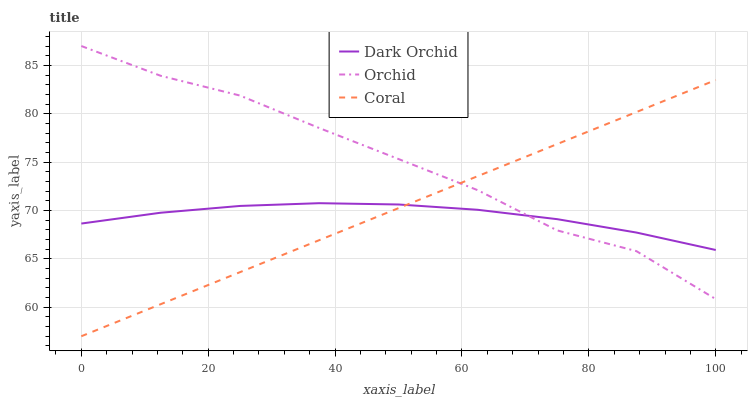Does Dark Orchid have the minimum area under the curve?
Answer yes or no. Yes. Does Orchid have the maximum area under the curve?
Answer yes or no. Yes. Does Orchid have the minimum area under the curve?
Answer yes or no. No. Does Dark Orchid have the maximum area under the curve?
Answer yes or no. No. Is Coral the smoothest?
Answer yes or no. Yes. Is Orchid the roughest?
Answer yes or no. Yes. Is Dark Orchid the smoothest?
Answer yes or no. No. Is Dark Orchid the roughest?
Answer yes or no. No. Does Orchid have the lowest value?
Answer yes or no. No. Does Orchid have the highest value?
Answer yes or no. Yes. Does Dark Orchid have the highest value?
Answer yes or no. No. Does Orchid intersect Dark Orchid?
Answer yes or no. Yes. Is Orchid less than Dark Orchid?
Answer yes or no. No. Is Orchid greater than Dark Orchid?
Answer yes or no. No. 